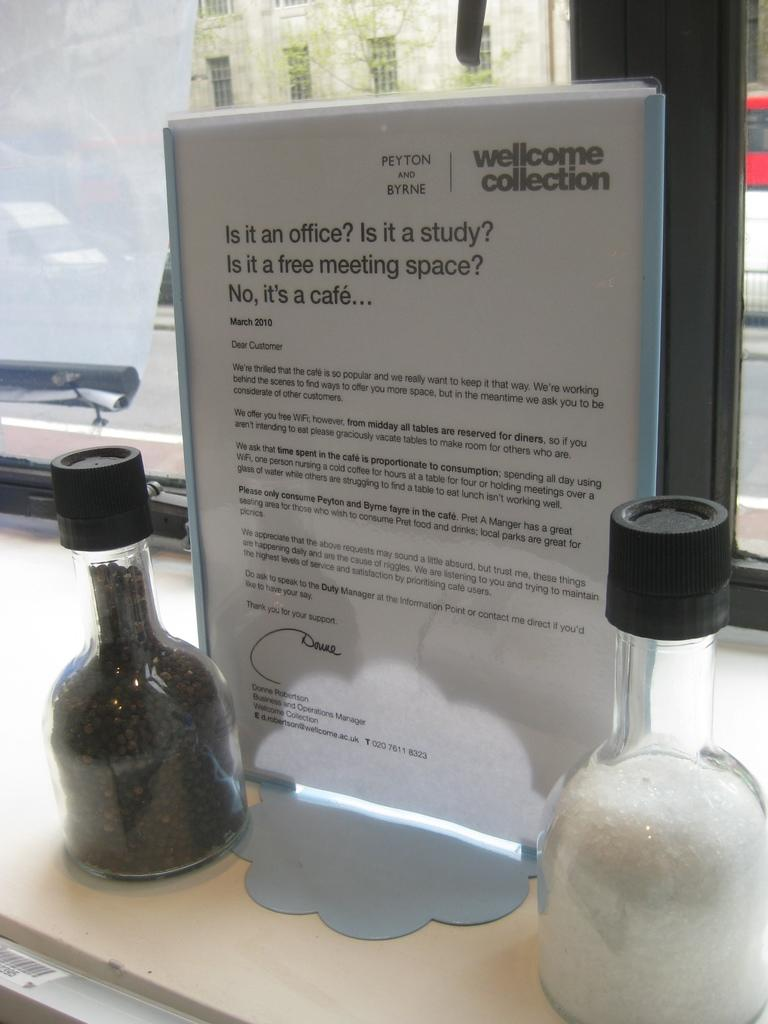<image>
Describe the image concisely. Sign in between two bottles that says "Wellcome Collection". 